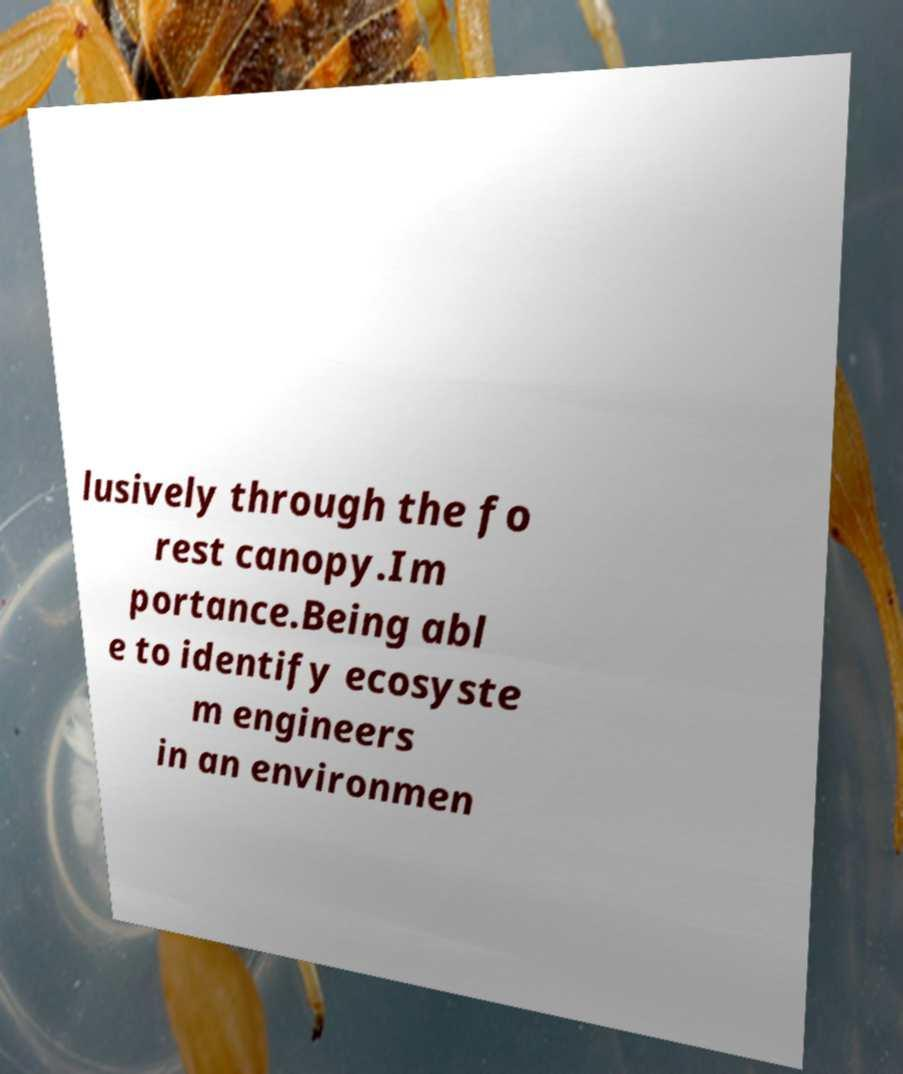Can you read and provide the text displayed in the image?This photo seems to have some interesting text. Can you extract and type it out for me? lusively through the fo rest canopy.Im portance.Being abl e to identify ecosyste m engineers in an environmen 